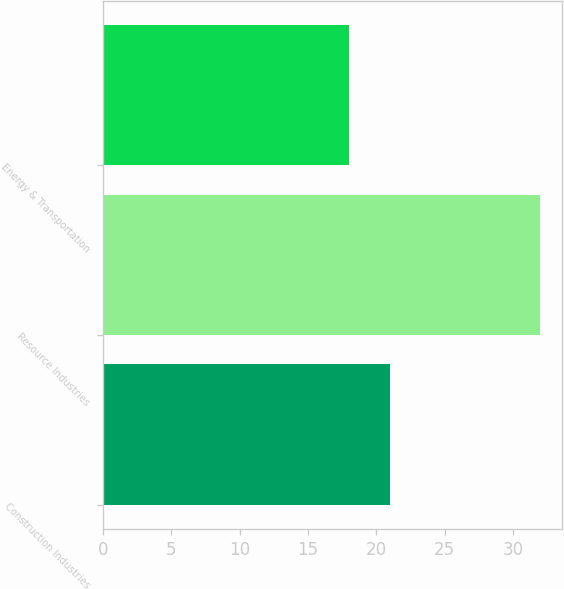<chart> <loc_0><loc_0><loc_500><loc_500><bar_chart><fcel>Construction Industries<fcel>Resource Industries<fcel>Energy & Transportation<nl><fcel>21<fcel>32<fcel>18<nl></chart> 